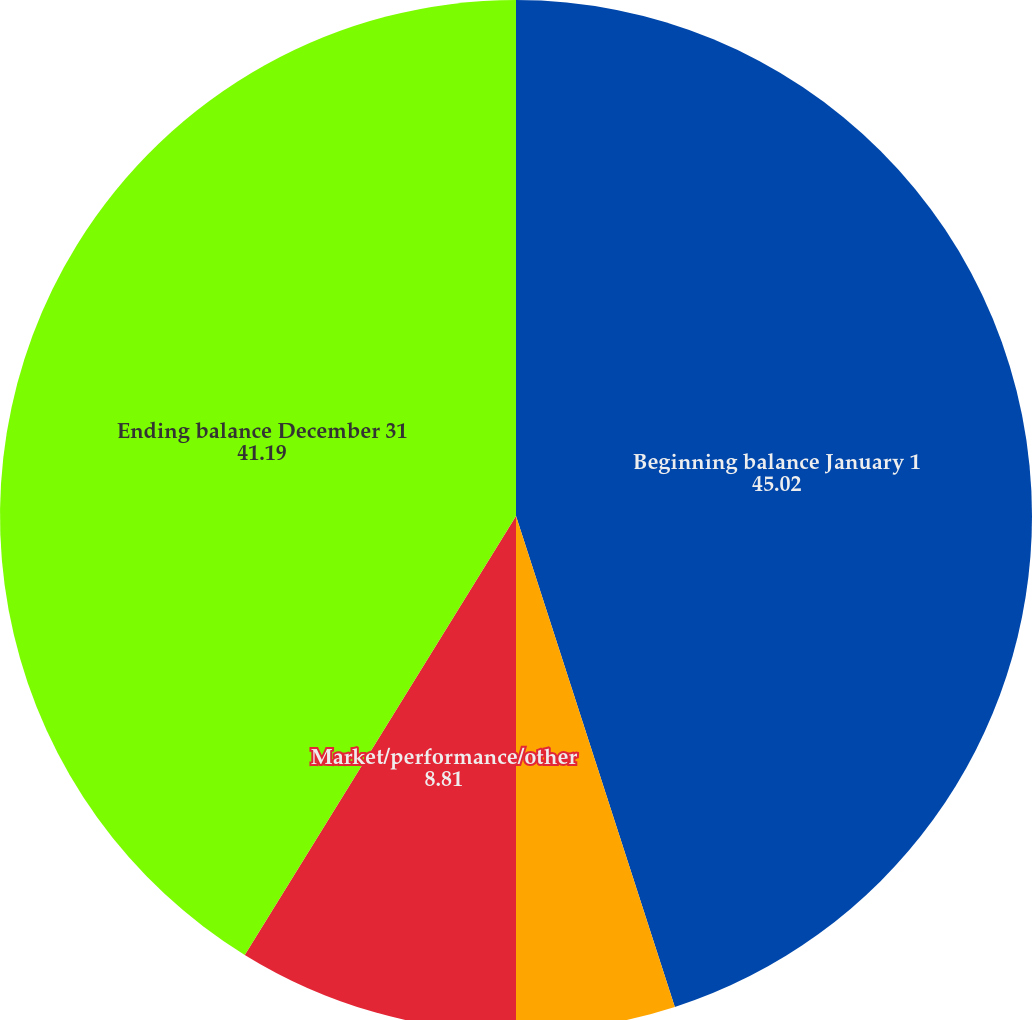<chart> <loc_0><loc_0><loc_500><loc_500><pie_chart><fcel>Beginning balance January 1<fcel>Net asset flows<fcel>Market/performance/other<fcel>Ending balance December 31<nl><fcel>45.02%<fcel>4.98%<fcel>8.81%<fcel>41.19%<nl></chart> 